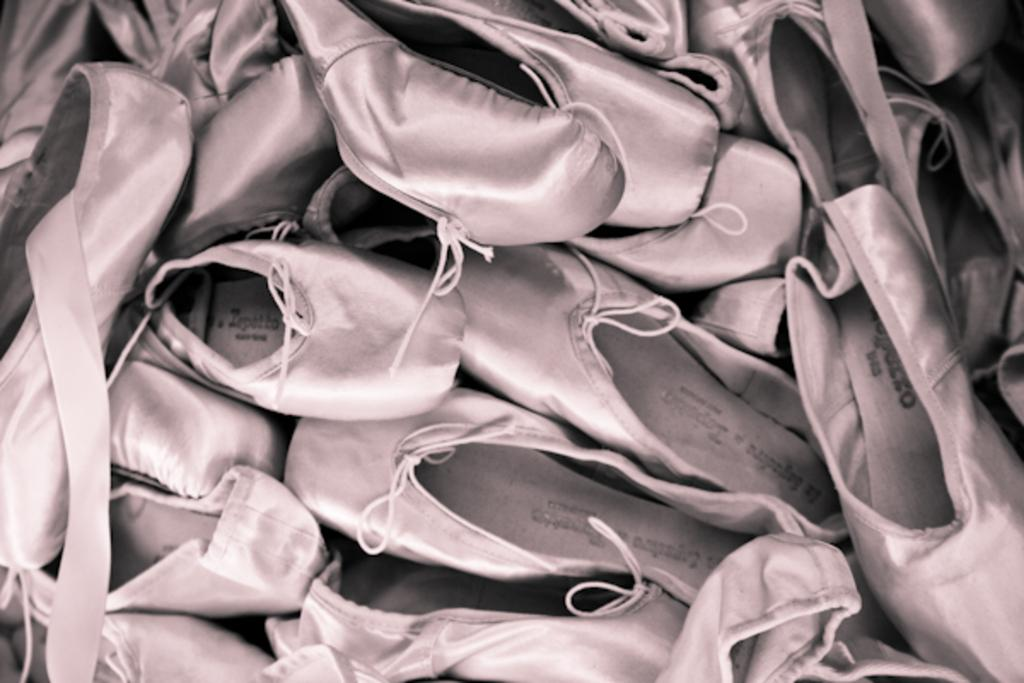What type of objects can be seen in the image? There are shoes in the image. What type of drink is being served in the image? There is no drink present in the image; it only features shoes. What type of structure can be seen in the background of the image? There is no structure visible in the image; it only features shoes. 